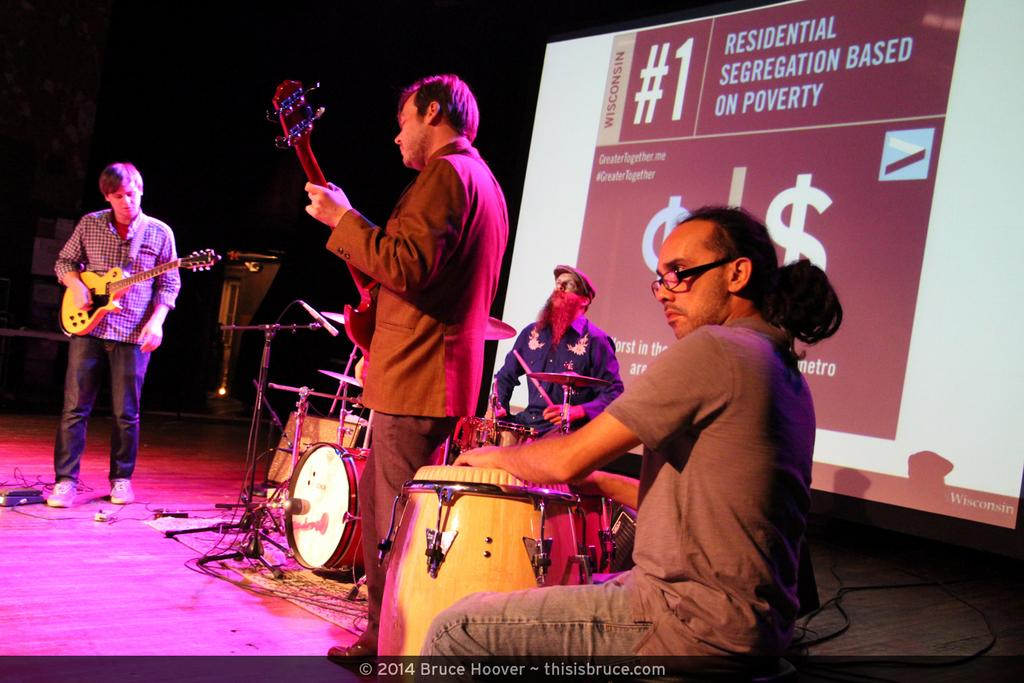How many people are in the image? There are four people in the image. What are the positions of the people in the image? Two of the people are standing, and two of the people are sitting. What type of group are the people in the image? It is a musical band. What instrument can be seen in the image? There is a guitar in the image. What else is present in the image besides the people and the guitar? There is a poster in the image. How many pens can be seen on the poster in the image? There are no pens visible in the image, as the poster is not described in detail. 